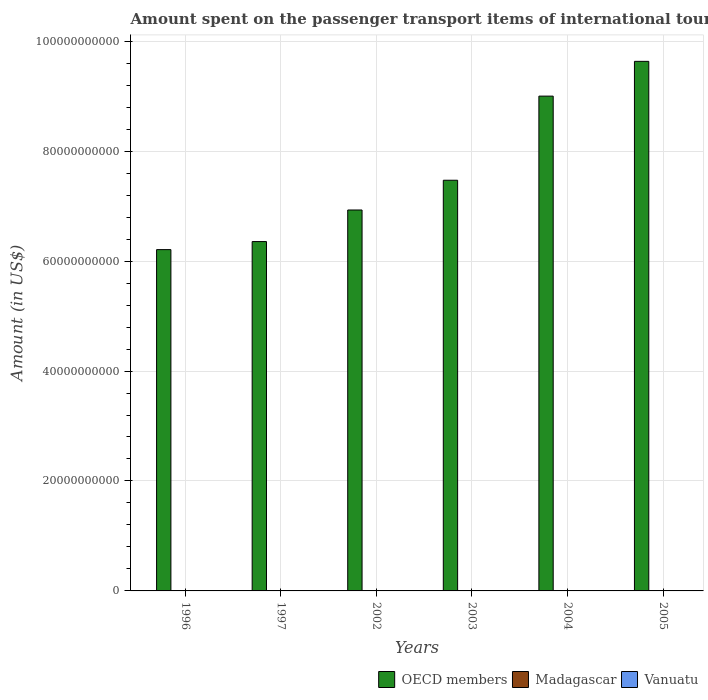Are the number of bars per tick equal to the number of legend labels?
Your answer should be very brief. Yes. How many bars are there on the 4th tick from the left?
Give a very brief answer. 3. What is the label of the 5th group of bars from the left?
Your answer should be compact. 2004. What is the amount spent on the passenger transport items of international tourists in Vanuatu in 2002?
Your answer should be very brief. 2.00e+06. Across all years, what is the maximum amount spent on the passenger transport items of international tourists in OECD members?
Provide a succinct answer. 9.63e+1. Across all years, what is the minimum amount spent on the passenger transport items of international tourists in OECD members?
Offer a terse response. 6.21e+1. In which year was the amount spent on the passenger transport items of international tourists in Vanuatu maximum?
Offer a very short reply. 1996. What is the total amount spent on the passenger transport items of international tourists in OECD members in the graph?
Make the answer very short. 4.56e+11. What is the difference between the amount spent on the passenger transport items of international tourists in OECD members in 2004 and that in 2005?
Your answer should be very brief. -6.32e+09. What is the difference between the amount spent on the passenger transport items of international tourists in Madagascar in 2005 and the amount spent on the passenger transport items of international tourists in Vanuatu in 2004?
Provide a succinct answer. 4.00e+06. What is the average amount spent on the passenger transport items of international tourists in Madagascar per year?
Your response must be concise. 1.57e+07. In the year 1997, what is the difference between the amount spent on the passenger transport items of international tourists in Madagascar and amount spent on the passenger transport items of international tourists in Vanuatu?
Keep it short and to the point. 1.60e+07. In how many years, is the amount spent on the passenger transport items of international tourists in Vanuatu greater than 16000000000 US$?
Keep it short and to the point. 0. What is the ratio of the amount spent on the passenger transport items of international tourists in OECD members in 2003 to that in 2005?
Ensure brevity in your answer.  0.78. What is the difference between the highest and the second highest amount spent on the passenger transport items of international tourists in Madagascar?
Your answer should be very brief. 1.10e+07. What is the difference between the highest and the lowest amount spent on the passenger transport items of international tourists in OECD members?
Give a very brief answer. 3.42e+1. What does the 1st bar from the left in 2003 represents?
Offer a very short reply. OECD members. Is it the case that in every year, the sum of the amount spent on the passenger transport items of international tourists in OECD members and amount spent on the passenger transport items of international tourists in Vanuatu is greater than the amount spent on the passenger transport items of international tourists in Madagascar?
Keep it short and to the point. Yes. Are all the bars in the graph horizontal?
Provide a short and direct response. No. How many years are there in the graph?
Offer a terse response. 6. What is the difference between two consecutive major ticks on the Y-axis?
Offer a terse response. 2.00e+1. Are the values on the major ticks of Y-axis written in scientific E-notation?
Your response must be concise. No. Does the graph contain any zero values?
Keep it short and to the point. No. What is the title of the graph?
Make the answer very short. Amount spent on the passenger transport items of international tourists. Does "Cameroon" appear as one of the legend labels in the graph?
Your answer should be compact. No. What is the label or title of the X-axis?
Keep it short and to the point. Years. What is the Amount (in US$) of OECD members in 1996?
Ensure brevity in your answer.  6.21e+1. What is the Amount (in US$) of Madagascar in 1996?
Offer a terse response. 1.70e+07. What is the Amount (in US$) of OECD members in 1997?
Provide a short and direct response. 6.35e+1. What is the Amount (in US$) in Madagascar in 1997?
Keep it short and to the point. 2.10e+07. What is the Amount (in US$) in Vanuatu in 1997?
Give a very brief answer. 5.00e+06. What is the Amount (in US$) in OECD members in 2002?
Give a very brief answer. 6.93e+1. What is the Amount (in US$) of Madagascar in 2002?
Make the answer very short. 3.20e+07. What is the Amount (in US$) of OECD members in 2003?
Your answer should be compact. 7.47e+1. What is the Amount (in US$) in Madagascar in 2003?
Ensure brevity in your answer.  3.00e+06. What is the Amount (in US$) of Vanuatu in 2003?
Your answer should be compact. 2.00e+06. What is the Amount (in US$) of OECD members in 2004?
Keep it short and to the point. 9.00e+1. What is the Amount (in US$) of Madagascar in 2004?
Offer a very short reply. 1.50e+07. What is the Amount (in US$) in Vanuatu in 2004?
Offer a terse response. 2.00e+06. What is the Amount (in US$) of OECD members in 2005?
Make the answer very short. 9.63e+1. What is the Amount (in US$) in Vanuatu in 2005?
Your answer should be very brief. 2.00e+06. Across all years, what is the maximum Amount (in US$) of OECD members?
Ensure brevity in your answer.  9.63e+1. Across all years, what is the maximum Amount (in US$) in Madagascar?
Your answer should be very brief. 3.20e+07. Across all years, what is the maximum Amount (in US$) of Vanuatu?
Offer a very short reply. 5.00e+06. Across all years, what is the minimum Amount (in US$) of OECD members?
Offer a very short reply. 6.21e+1. What is the total Amount (in US$) of OECD members in the graph?
Ensure brevity in your answer.  4.56e+11. What is the total Amount (in US$) of Madagascar in the graph?
Your answer should be very brief. 9.40e+07. What is the total Amount (in US$) in Vanuatu in the graph?
Ensure brevity in your answer.  1.80e+07. What is the difference between the Amount (in US$) in OECD members in 1996 and that in 1997?
Keep it short and to the point. -1.46e+09. What is the difference between the Amount (in US$) in OECD members in 1996 and that in 2002?
Make the answer very short. -7.21e+09. What is the difference between the Amount (in US$) of Madagascar in 1996 and that in 2002?
Provide a succinct answer. -1.50e+07. What is the difference between the Amount (in US$) of Vanuatu in 1996 and that in 2002?
Your response must be concise. 3.00e+06. What is the difference between the Amount (in US$) of OECD members in 1996 and that in 2003?
Your response must be concise. -1.26e+1. What is the difference between the Amount (in US$) in Madagascar in 1996 and that in 2003?
Keep it short and to the point. 1.40e+07. What is the difference between the Amount (in US$) of OECD members in 1996 and that in 2004?
Ensure brevity in your answer.  -2.79e+1. What is the difference between the Amount (in US$) in Madagascar in 1996 and that in 2004?
Make the answer very short. 2.00e+06. What is the difference between the Amount (in US$) in Vanuatu in 1996 and that in 2004?
Ensure brevity in your answer.  3.00e+06. What is the difference between the Amount (in US$) in OECD members in 1996 and that in 2005?
Offer a very short reply. -3.42e+1. What is the difference between the Amount (in US$) in Madagascar in 1996 and that in 2005?
Offer a terse response. 1.10e+07. What is the difference between the Amount (in US$) in Vanuatu in 1996 and that in 2005?
Keep it short and to the point. 3.00e+06. What is the difference between the Amount (in US$) in OECD members in 1997 and that in 2002?
Provide a short and direct response. -5.75e+09. What is the difference between the Amount (in US$) of Madagascar in 1997 and that in 2002?
Offer a very short reply. -1.10e+07. What is the difference between the Amount (in US$) of Vanuatu in 1997 and that in 2002?
Keep it short and to the point. 3.00e+06. What is the difference between the Amount (in US$) in OECD members in 1997 and that in 2003?
Provide a short and direct response. -1.12e+1. What is the difference between the Amount (in US$) of Madagascar in 1997 and that in 2003?
Offer a very short reply. 1.80e+07. What is the difference between the Amount (in US$) of OECD members in 1997 and that in 2004?
Offer a very short reply. -2.65e+1. What is the difference between the Amount (in US$) in Madagascar in 1997 and that in 2004?
Provide a short and direct response. 6.00e+06. What is the difference between the Amount (in US$) in Vanuatu in 1997 and that in 2004?
Your response must be concise. 3.00e+06. What is the difference between the Amount (in US$) of OECD members in 1997 and that in 2005?
Ensure brevity in your answer.  -3.28e+1. What is the difference between the Amount (in US$) in Madagascar in 1997 and that in 2005?
Your response must be concise. 1.50e+07. What is the difference between the Amount (in US$) of Vanuatu in 1997 and that in 2005?
Ensure brevity in your answer.  3.00e+06. What is the difference between the Amount (in US$) in OECD members in 2002 and that in 2003?
Provide a short and direct response. -5.41e+09. What is the difference between the Amount (in US$) in Madagascar in 2002 and that in 2003?
Ensure brevity in your answer.  2.90e+07. What is the difference between the Amount (in US$) in Vanuatu in 2002 and that in 2003?
Your answer should be compact. 0. What is the difference between the Amount (in US$) in OECD members in 2002 and that in 2004?
Your answer should be very brief. -2.07e+1. What is the difference between the Amount (in US$) in Madagascar in 2002 and that in 2004?
Your answer should be compact. 1.70e+07. What is the difference between the Amount (in US$) in OECD members in 2002 and that in 2005?
Give a very brief answer. -2.70e+1. What is the difference between the Amount (in US$) of Madagascar in 2002 and that in 2005?
Your response must be concise. 2.60e+07. What is the difference between the Amount (in US$) of Vanuatu in 2002 and that in 2005?
Your answer should be very brief. 0. What is the difference between the Amount (in US$) in OECD members in 2003 and that in 2004?
Give a very brief answer. -1.53e+1. What is the difference between the Amount (in US$) of Madagascar in 2003 and that in 2004?
Offer a terse response. -1.20e+07. What is the difference between the Amount (in US$) of Vanuatu in 2003 and that in 2004?
Your answer should be compact. 0. What is the difference between the Amount (in US$) in OECD members in 2003 and that in 2005?
Offer a very short reply. -2.16e+1. What is the difference between the Amount (in US$) of Madagascar in 2003 and that in 2005?
Your answer should be very brief. -3.00e+06. What is the difference between the Amount (in US$) of OECD members in 2004 and that in 2005?
Offer a very short reply. -6.32e+09. What is the difference between the Amount (in US$) in Madagascar in 2004 and that in 2005?
Ensure brevity in your answer.  9.00e+06. What is the difference between the Amount (in US$) in Vanuatu in 2004 and that in 2005?
Offer a terse response. 0. What is the difference between the Amount (in US$) in OECD members in 1996 and the Amount (in US$) in Madagascar in 1997?
Your answer should be very brief. 6.21e+1. What is the difference between the Amount (in US$) in OECD members in 1996 and the Amount (in US$) in Vanuatu in 1997?
Keep it short and to the point. 6.21e+1. What is the difference between the Amount (in US$) in OECD members in 1996 and the Amount (in US$) in Madagascar in 2002?
Your response must be concise. 6.21e+1. What is the difference between the Amount (in US$) in OECD members in 1996 and the Amount (in US$) in Vanuatu in 2002?
Offer a terse response. 6.21e+1. What is the difference between the Amount (in US$) in Madagascar in 1996 and the Amount (in US$) in Vanuatu in 2002?
Offer a terse response. 1.50e+07. What is the difference between the Amount (in US$) in OECD members in 1996 and the Amount (in US$) in Madagascar in 2003?
Offer a very short reply. 6.21e+1. What is the difference between the Amount (in US$) in OECD members in 1996 and the Amount (in US$) in Vanuatu in 2003?
Your response must be concise. 6.21e+1. What is the difference between the Amount (in US$) in Madagascar in 1996 and the Amount (in US$) in Vanuatu in 2003?
Your response must be concise. 1.50e+07. What is the difference between the Amount (in US$) of OECD members in 1996 and the Amount (in US$) of Madagascar in 2004?
Offer a terse response. 6.21e+1. What is the difference between the Amount (in US$) in OECD members in 1996 and the Amount (in US$) in Vanuatu in 2004?
Offer a terse response. 6.21e+1. What is the difference between the Amount (in US$) in Madagascar in 1996 and the Amount (in US$) in Vanuatu in 2004?
Offer a very short reply. 1.50e+07. What is the difference between the Amount (in US$) of OECD members in 1996 and the Amount (in US$) of Madagascar in 2005?
Offer a very short reply. 6.21e+1. What is the difference between the Amount (in US$) in OECD members in 1996 and the Amount (in US$) in Vanuatu in 2005?
Ensure brevity in your answer.  6.21e+1. What is the difference between the Amount (in US$) of Madagascar in 1996 and the Amount (in US$) of Vanuatu in 2005?
Your response must be concise. 1.50e+07. What is the difference between the Amount (in US$) in OECD members in 1997 and the Amount (in US$) in Madagascar in 2002?
Offer a terse response. 6.35e+1. What is the difference between the Amount (in US$) of OECD members in 1997 and the Amount (in US$) of Vanuatu in 2002?
Keep it short and to the point. 6.35e+1. What is the difference between the Amount (in US$) in Madagascar in 1997 and the Amount (in US$) in Vanuatu in 2002?
Your response must be concise. 1.90e+07. What is the difference between the Amount (in US$) of OECD members in 1997 and the Amount (in US$) of Madagascar in 2003?
Ensure brevity in your answer.  6.35e+1. What is the difference between the Amount (in US$) in OECD members in 1997 and the Amount (in US$) in Vanuatu in 2003?
Your response must be concise. 6.35e+1. What is the difference between the Amount (in US$) of Madagascar in 1997 and the Amount (in US$) of Vanuatu in 2003?
Offer a very short reply. 1.90e+07. What is the difference between the Amount (in US$) of OECD members in 1997 and the Amount (in US$) of Madagascar in 2004?
Ensure brevity in your answer.  6.35e+1. What is the difference between the Amount (in US$) of OECD members in 1997 and the Amount (in US$) of Vanuatu in 2004?
Your answer should be compact. 6.35e+1. What is the difference between the Amount (in US$) of Madagascar in 1997 and the Amount (in US$) of Vanuatu in 2004?
Provide a succinct answer. 1.90e+07. What is the difference between the Amount (in US$) in OECD members in 1997 and the Amount (in US$) in Madagascar in 2005?
Provide a succinct answer. 6.35e+1. What is the difference between the Amount (in US$) of OECD members in 1997 and the Amount (in US$) of Vanuatu in 2005?
Provide a short and direct response. 6.35e+1. What is the difference between the Amount (in US$) of Madagascar in 1997 and the Amount (in US$) of Vanuatu in 2005?
Provide a succinct answer. 1.90e+07. What is the difference between the Amount (in US$) of OECD members in 2002 and the Amount (in US$) of Madagascar in 2003?
Ensure brevity in your answer.  6.93e+1. What is the difference between the Amount (in US$) of OECD members in 2002 and the Amount (in US$) of Vanuatu in 2003?
Your answer should be compact. 6.93e+1. What is the difference between the Amount (in US$) in Madagascar in 2002 and the Amount (in US$) in Vanuatu in 2003?
Your response must be concise. 3.00e+07. What is the difference between the Amount (in US$) in OECD members in 2002 and the Amount (in US$) in Madagascar in 2004?
Ensure brevity in your answer.  6.93e+1. What is the difference between the Amount (in US$) of OECD members in 2002 and the Amount (in US$) of Vanuatu in 2004?
Your answer should be very brief. 6.93e+1. What is the difference between the Amount (in US$) in Madagascar in 2002 and the Amount (in US$) in Vanuatu in 2004?
Provide a short and direct response. 3.00e+07. What is the difference between the Amount (in US$) of OECD members in 2002 and the Amount (in US$) of Madagascar in 2005?
Offer a very short reply. 6.93e+1. What is the difference between the Amount (in US$) of OECD members in 2002 and the Amount (in US$) of Vanuatu in 2005?
Give a very brief answer. 6.93e+1. What is the difference between the Amount (in US$) of Madagascar in 2002 and the Amount (in US$) of Vanuatu in 2005?
Offer a terse response. 3.00e+07. What is the difference between the Amount (in US$) in OECD members in 2003 and the Amount (in US$) in Madagascar in 2004?
Offer a very short reply. 7.47e+1. What is the difference between the Amount (in US$) in OECD members in 2003 and the Amount (in US$) in Vanuatu in 2004?
Make the answer very short. 7.47e+1. What is the difference between the Amount (in US$) in OECD members in 2003 and the Amount (in US$) in Madagascar in 2005?
Keep it short and to the point. 7.47e+1. What is the difference between the Amount (in US$) in OECD members in 2003 and the Amount (in US$) in Vanuatu in 2005?
Keep it short and to the point. 7.47e+1. What is the difference between the Amount (in US$) in OECD members in 2004 and the Amount (in US$) in Madagascar in 2005?
Make the answer very short. 9.00e+1. What is the difference between the Amount (in US$) in OECD members in 2004 and the Amount (in US$) in Vanuatu in 2005?
Offer a very short reply. 9.00e+1. What is the difference between the Amount (in US$) of Madagascar in 2004 and the Amount (in US$) of Vanuatu in 2005?
Offer a very short reply. 1.30e+07. What is the average Amount (in US$) of OECD members per year?
Provide a succinct answer. 7.60e+1. What is the average Amount (in US$) of Madagascar per year?
Your answer should be very brief. 1.57e+07. What is the average Amount (in US$) in Vanuatu per year?
Offer a terse response. 3.00e+06. In the year 1996, what is the difference between the Amount (in US$) of OECD members and Amount (in US$) of Madagascar?
Provide a short and direct response. 6.21e+1. In the year 1996, what is the difference between the Amount (in US$) in OECD members and Amount (in US$) in Vanuatu?
Provide a short and direct response. 6.21e+1. In the year 1997, what is the difference between the Amount (in US$) of OECD members and Amount (in US$) of Madagascar?
Provide a short and direct response. 6.35e+1. In the year 1997, what is the difference between the Amount (in US$) in OECD members and Amount (in US$) in Vanuatu?
Your answer should be compact. 6.35e+1. In the year 1997, what is the difference between the Amount (in US$) of Madagascar and Amount (in US$) of Vanuatu?
Offer a terse response. 1.60e+07. In the year 2002, what is the difference between the Amount (in US$) in OECD members and Amount (in US$) in Madagascar?
Your response must be concise. 6.93e+1. In the year 2002, what is the difference between the Amount (in US$) in OECD members and Amount (in US$) in Vanuatu?
Your answer should be very brief. 6.93e+1. In the year 2002, what is the difference between the Amount (in US$) in Madagascar and Amount (in US$) in Vanuatu?
Provide a succinct answer. 3.00e+07. In the year 2003, what is the difference between the Amount (in US$) of OECD members and Amount (in US$) of Madagascar?
Your answer should be compact. 7.47e+1. In the year 2003, what is the difference between the Amount (in US$) of OECD members and Amount (in US$) of Vanuatu?
Ensure brevity in your answer.  7.47e+1. In the year 2003, what is the difference between the Amount (in US$) in Madagascar and Amount (in US$) in Vanuatu?
Ensure brevity in your answer.  1.00e+06. In the year 2004, what is the difference between the Amount (in US$) of OECD members and Amount (in US$) of Madagascar?
Make the answer very short. 9.00e+1. In the year 2004, what is the difference between the Amount (in US$) of OECD members and Amount (in US$) of Vanuatu?
Provide a succinct answer. 9.00e+1. In the year 2004, what is the difference between the Amount (in US$) of Madagascar and Amount (in US$) of Vanuatu?
Provide a short and direct response. 1.30e+07. In the year 2005, what is the difference between the Amount (in US$) of OECD members and Amount (in US$) of Madagascar?
Give a very brief answer. 9.63e+1. In the year 2005, what is the difference between the Amount (in US$) in OECD members and Amount (in US$) in Vanuatu?
Keep it short and to the point. 9.63e+1. In the year 2005, what is the difference between the Amount (in US$) of Madagascar and Amount (in US$) of Vanuatu?
Offer a very short reply. 4.00e+06. What is the ratio of the Amount (in US$) in Madagascar in 1996 to that in 1997?
Ensure brevity in your answer.  0.81. What is the ratio of the Amount (in US$) of Vanuatu in 1996 to that in 1997?
Your answer should be very brief. 1. What is the ratio of the Amount (in US$) in OECD members in 1996 to that in 2002?
Offer a terse response. 0.9. What is the ratio of the Amount (in US$) of Madagascar in 1996 to that in 2002?
Provide a short and direct response. 0.53. What is the ratio of the Amount (in US$) in Vanuatu in 1996 to that in 2002?
Ensure brevity in your answer.  2.5. What is the ratio of the Amount (in US$) in OECD members in 1996 to that in 2003?
Make the answer very short. 0.83. What is the ratio of the Amount (in US$) of Madagascar in 1996 to that in 2003?
Offer a terse response. 5.67. What is the ratio of the Amount (in US$) of OECD members in 1996 to that in 2004?
Provide a succinct answer. 0.69. What is the ratio of the Amount (in US$) of Madagascar in 1996 to that in 2004?
Your response must be concise. 1.13. What is the ratio of the Amount (in US$) of OECD members in 1996 to that in 2005?
Offer a very short reply. 0.64. What is the ratio of the Amount (in US$) of Madagascar in 1996 to that in 2005?
Provide a short and direct response. 2.83. What is the ratio of the Amount (in US$) in OECD members in 1997 to that in 2002?
Provide a succinct answer. 0.92. What is the ratio of the Amount (in US$) in Madagascar in 1997 to that in 2002?
Offer a terse response. 0.66. What is the ratio of the Amount (in US$) of OECD members in 1997 to that in 2003?
Give a very brief answer. 0.85. What is the ratio of the Amount (in US$) in Vanuatu in 1997 to that in 2003?
Give a very brief answer. 2.5. What is the ratio of the Amount (in US$) in OECD members in 1997 to that in 2004?
Your answer should be compact. 0.71. What is the ratio of the Amount (in US$) in Vanuatu in 1997 to that in 2004?
Your answer should be compact. 2.5. What is the ratio of the Amount (in US$) in OECD members in 1997 to that in 2005?
Give a very brief answer. 0.66. What is the ratio of the Amount (in US$) of Madagascar in 1997 to that in 2005?
Your response must be concise. 3.5. What is the ratio of the Amount (in US$) of Vanuatu in 1997 to that in 2005?
Provide a succinct answer. 2.5. What is the ratio of the Amount (in US$) in OECD members in 2002 to that in 2003?
Offer a terse response. 0.93. What is the ratio of the Amount (in US$) in Madagascar in 2002 to that in 2003?
Your answer should be compact. 10.67. What is the ratio of the Amount (in US$) of Vanuatu in 2002 to that in 2003?
Your response must be concise. 1. What is the ratio of the Amount (in US$) of OECD members in 2002 to that in 2004?
Offer a terse response. 0.77. What is the ratio of the Amount (in US$) of Madagascar in 2002 to that in 2004?
Provide a succinct answer. 2.13. What is the ratio of the Amount (in US$) in Vanuatu in 2002 to that in 2004?
Ensure brevity in your answer.  1. What is the ratio of the Amount (in US$) of OECD members in 2002 to that in 2005?
Provide a succinct answer. 0.72. What is the ratio of the Amount (in US$) in Madagascar in 2002 to that in 2005?
Make the answer very short. 5.33. What is the ratio of the Amount (in US$) of OECD members in 2003 to that in 2004?
Your response must be concise. 0.83. What is the ratio of the Amount (in US$) of OECD members in 2003 to that in 2005?
Your answer should be very brief. 0.78. What is the ratio of the Amount (in US$) of Vanuatu in 2003 to that in 2005?
Offer a terse response. 1. What is the ratio of the Amount (in US$) of OECD members in 2004 to that in 2005?
Make the answer very short. 0.93. What is the difference between the highest and the second highest Amount (in US$) of OECD members?
Offer a terse response. 6.32e+09. What is the difference between the highest and the second highest Amount (in US$) in Madagascar?
Your response must be concise. 1.10e+07. What is the difference between the highest and the second highest Amount (in US$) in Vanuatu?
Provide a succinct answer. 0. What is the difference between the highest and the lowest Amount (in US$) in OECD members?
Offer a terse response. 3.42e+1. What is the difference between the highest and the lowest Amount (in US$) of Madagascar?
Offer a very short reply. 2.90e+07. 